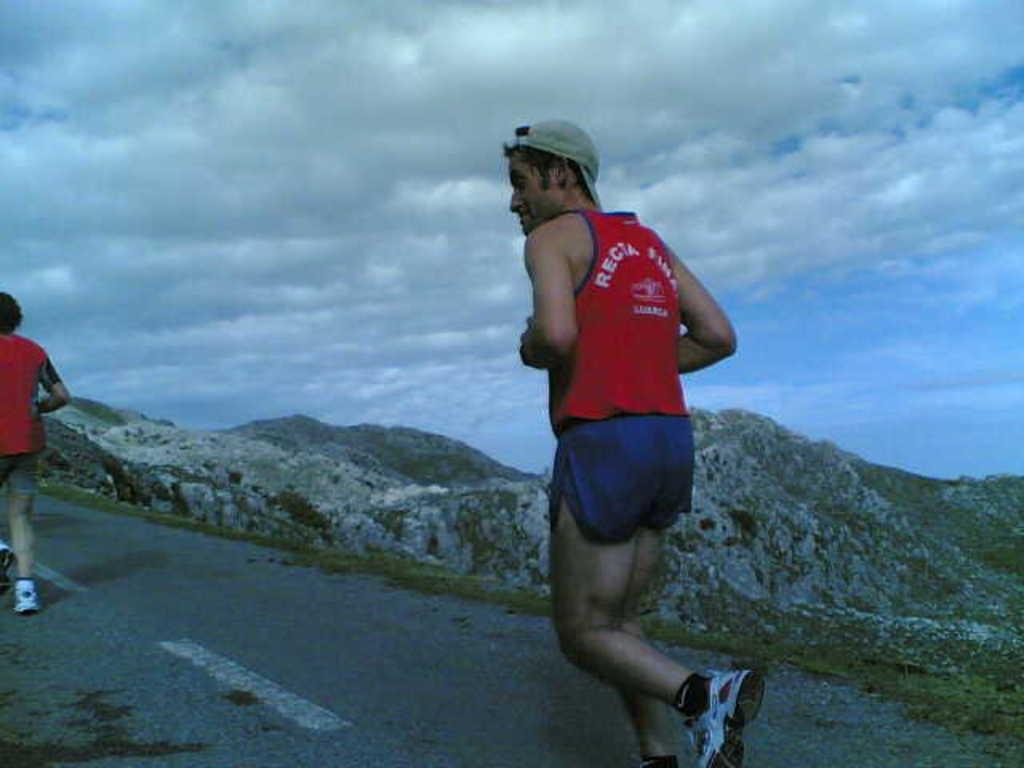How would you summarize this image in a sentence or two? There are two persons running on the road. Background we can see hills and sky with clouds. 